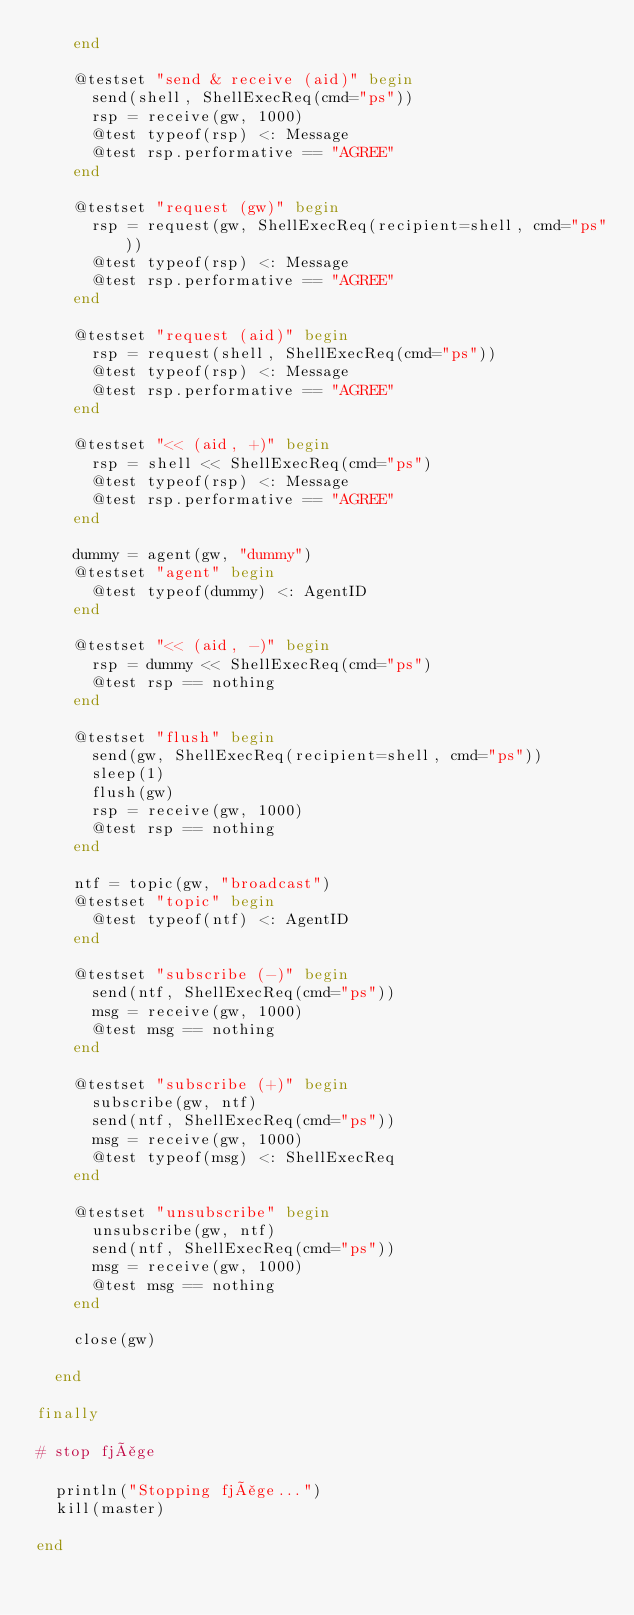Convert code to text. <code><loc_0><loc_0><loc_500><loc_500><_Julia_>    end

    @testset "send & receive (aid)" begin
      send(shell, ShellExecReq(cmd="ps"))
      rsp = receive(gw, 1000)
      @test typeof(rsp) <: Message
      @test rsp.performative == "AGREE"
    end

    @testset "request (gw)" begin
      rsp = request(gw, ShellExecReq(recipient=shell, cmd="ps"))
      @test typeof(rsp) <: Message
      @test rsp.performative == "AGREE"
    end

    @testset "request (aid)" begin
      rsp = request(shell, ShellExecReq(cmd="ps"))
      @test typeof(rsp) <: Message
      @test rsp.performative == "AGREE"
    end

    @testset "<< (aid, +)" begin
      rsp = shell << ShellExecReq(cmd="ps")
      @test typeof(rsp) <: Message
      @test rsp.performative == "AGREE"
    end

    dummy = agent(gw, "dummy")
    @testset "agent" begin
      @test typeof(dummy) <: AgentID
    end

    @testset "<< (aid, -)" begin
      rsp = dummy << ShellExecReq(cmd="ps")
      @test rsp == nothing
    end

    @testset "flush" begin
      send(gw, ShellExecReq(recipient=shell, cmd="ps"))
      sleep(1)
      flush(gw)
      rsp = receive(gw, 1000)
      @test rsp == nothing
    end

    ntf = topic(gw, "broadcast")
    @testset "topic" begin
      @test typeof(ntf) <: AgentID
    end

    @testset "subscribe (-)" begin
      send(ntf, ShellExecReq(cmd="ps"))
      msg = receive(gw, 1000)
      @test msg == nothing
    end

    @testset "subscribe (+)" begin
      subscribe(gw, ntf)
      send(ntf, ShellExecReq(cmd="ps"))
      msg = receive(gw, 1000)
      @test typeof(msg) <: ShellExecReq
    end

    @testset "unsubscribe" begin
      unsubscribe(gw, ntf)
      send(ntf, ShellExecReq(cmd="ps"))
      msg = receive(gw, 1000)
      @test msg == nothing
    end

    close(gw)

  end

finally

# stop fjåge

  println("Stopping fjåge...")
  kill(master)

end
</code> 